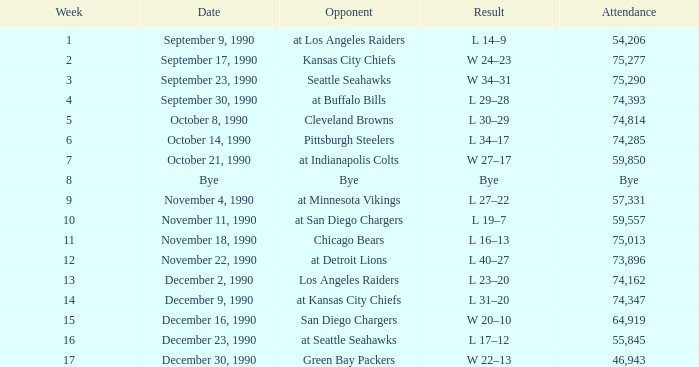What is the latest week with an attendance of 74,162? 13.0. 